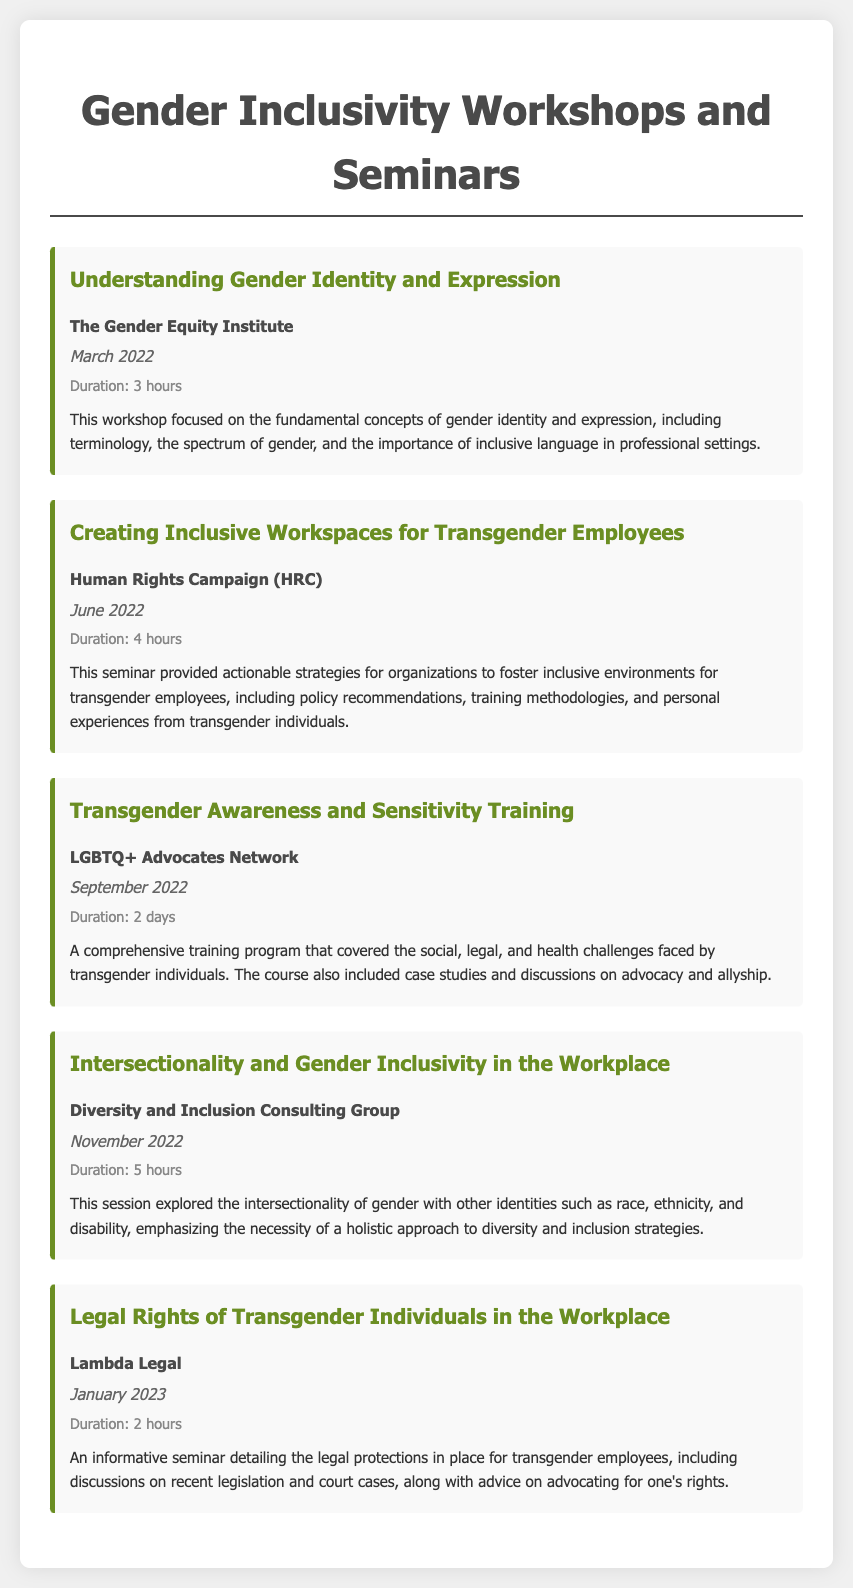what is the title of the first workshop? The first workshop is titled "Understanding Gender Identity and Expression."
Answer: Understanding Gender Identity and Expression who organized the seminar on creating inclusive workspaces? The seminar was organized by the Human Rights Campaign (HRC).
Answer: Human Rights Campaign (HRC) how long was the transgender awareness training? The transgender awareness training lasted for 2 days.
Answer: 2 days when was the workshop on intersectionality held? The workshop on intersectionality was held in November 2022.
Answer: November 2022 what main topics were covered in the legal rights seminar? The seminar detailed the legal protections for transgender employees and discussed recent legislation and court cases.
Answer: Legal protections for transgender employees which workshop emphasizes a holistic approach to diversity? The workshop titled "Intersectionality and Gender Inclusivity in the Workplace" emphasizes a holistic approach.
Answer: Intersectionality and Gender Inclusivity in the Workplace how many hours was the Creating Inclusive Workspaces seminar? The Creating Inclusive Workspaces seminar was 4 hours long.
Answer: 4 hours what organization conducted the transgender awareness and sensitivity training? The training was conducted by the LGBTQ+ Advocates Network.
Answer: LGBTQ+ Advocates Network which workshop discusses advocacy and allyship? The workshop titled "Transgender Awareness and Sensitivity Training" discusses advocacy and allyship.
Answer: Transgender Awareness and Sensitivity Training 